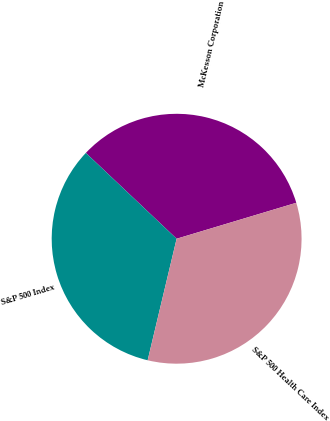Convert chart. <chart><loc_0><loc_0><loc_500><loc_500><pie_chart><fcel>McKesson Corporation<fcel>S&P 500 Index<fcel>S&P 500 Health Care Index<nl><fcel>33.3%<fcel>33.33%<fcel>33.37%<nl></chart> 